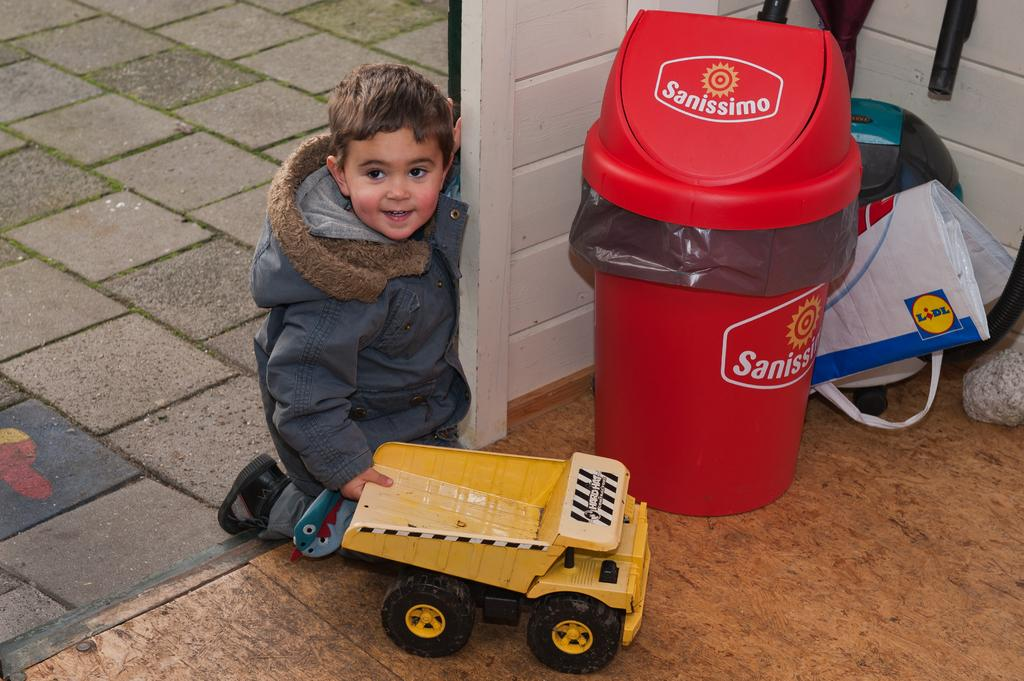What is the main subject of the image? There is a child in the image. What is the child doing in the image? The child is sitting on his knees. What object is the child holding in the image? The child is holding a toy truck. What type of small, round objects can be seen in the image? There are marbles visible in the image. What is the surface that the child is sitting on? The floor is present in the image. Where is the dustbin located in the image? There is a dustbin on the right side of the image. What is covering the dustbin in the image? There is a cover associated with the dustbin. What can be seen on the right side of the image besides the dustbin? There are pipes visible on the right side of the image. What season is depicted in the image? The provided facts do not mention any seasonal details, so it cannot be determined from the image. 